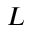<formula> <loc_0><loc_0><loc_500><loc_500>L</formula> 